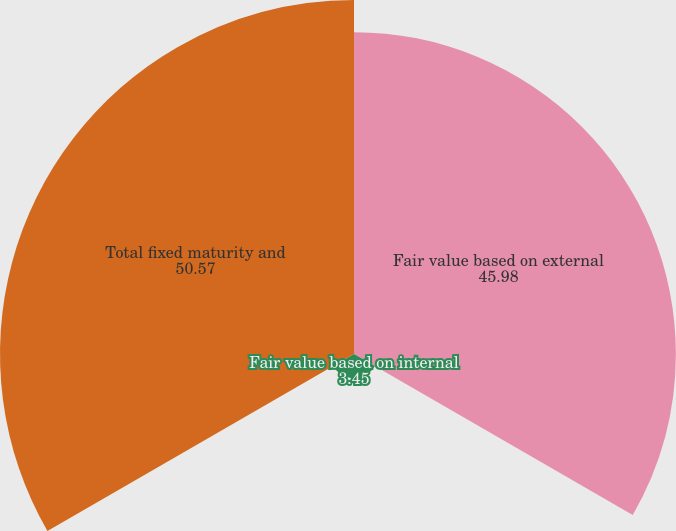Convert chart to OTSL. <chart><loc_0><loc_0><loc_500><loc_500><pie_chart><fcel>Fair value based on external<fcel>Fair value based on internal<fcel>Total fixed maturity and<nl><fcel>45.98%<fcel>3.45%<fcel>50.57%<nl></chart> 